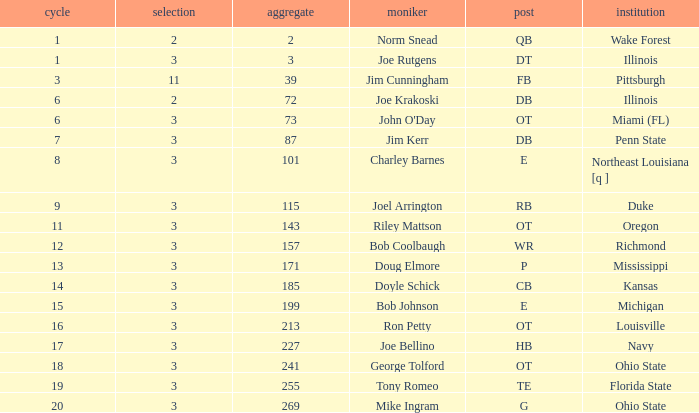How many overalls have charley barnes as the name, with a pick less than 3? None. 